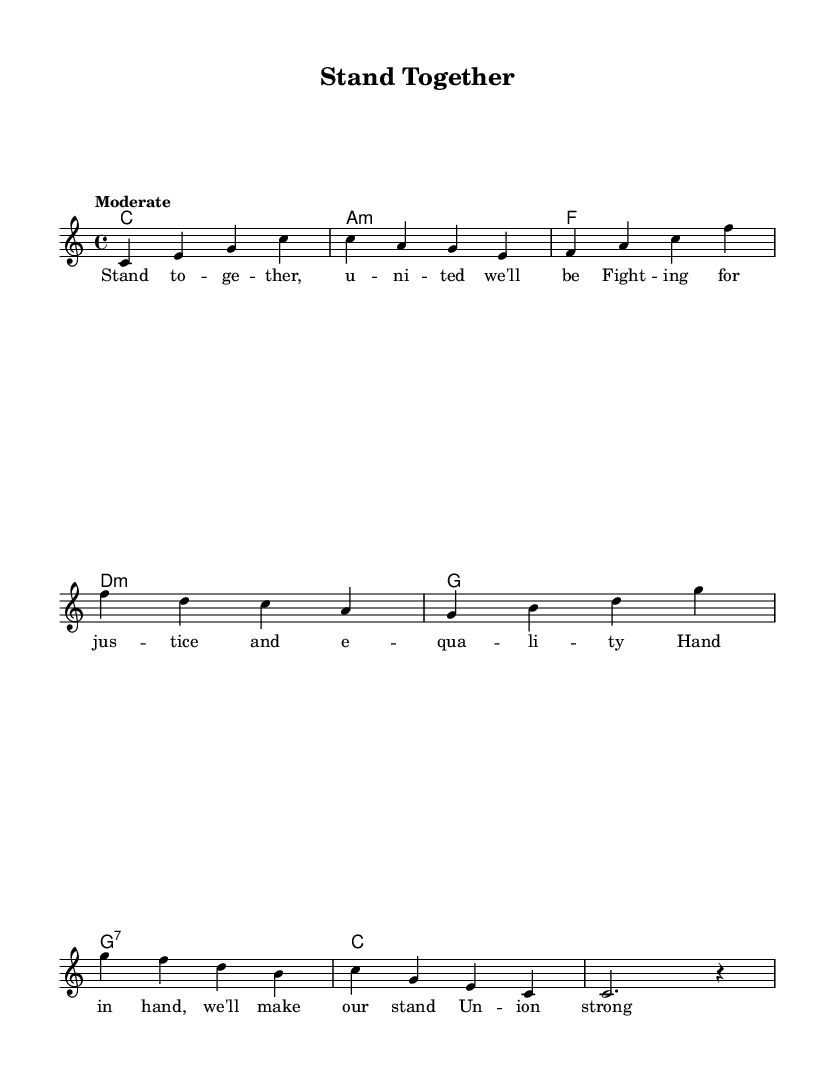What is the key signature of this music? The key signature is C major, which has no sharps or flats.
Answer: C major What is the time signature of this music? The time signature is indicated at the beginning of the piece, showing that there are four beats in each measure.
Answer: 4/4 What is the tempo marking of the song? The tempo is labeled as "Moderate", indicating a moderate pace.
Answer: Moderate How many measures are in the melody section? The melody provided has a total of eight measures, as each vertical bar represents a measure.
Answer: Eight What is the harmonization for the first measure? In the first measure, the chords are C major, as indicated by the chord symbol.
Answer: C What lyrical theme is conveyed in the music? The lyrics express themes of unity, justice, and strength in solidarity, which are central to the song's message.
Answer: Solidarity Name the last chord of the piece. The last chord is C major, completing the harmonization of the melody.
Answer: C 